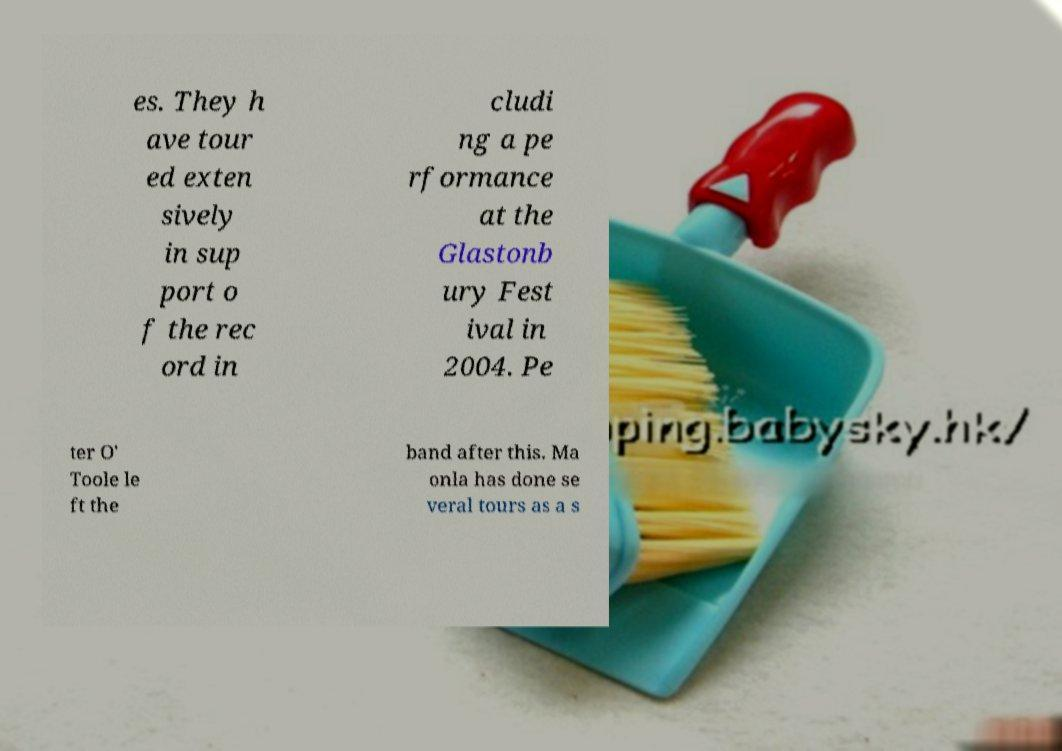Please identify and transcribe the text found in this image. es. They h ave tour ed exten sively in sup port o f the rec ord in cludi ng a pe rformance at the Glastonb ury Fest ival in 2004. Pe ter O' Toole le ft the band after this. Ma onla has done se veral tours as a s 